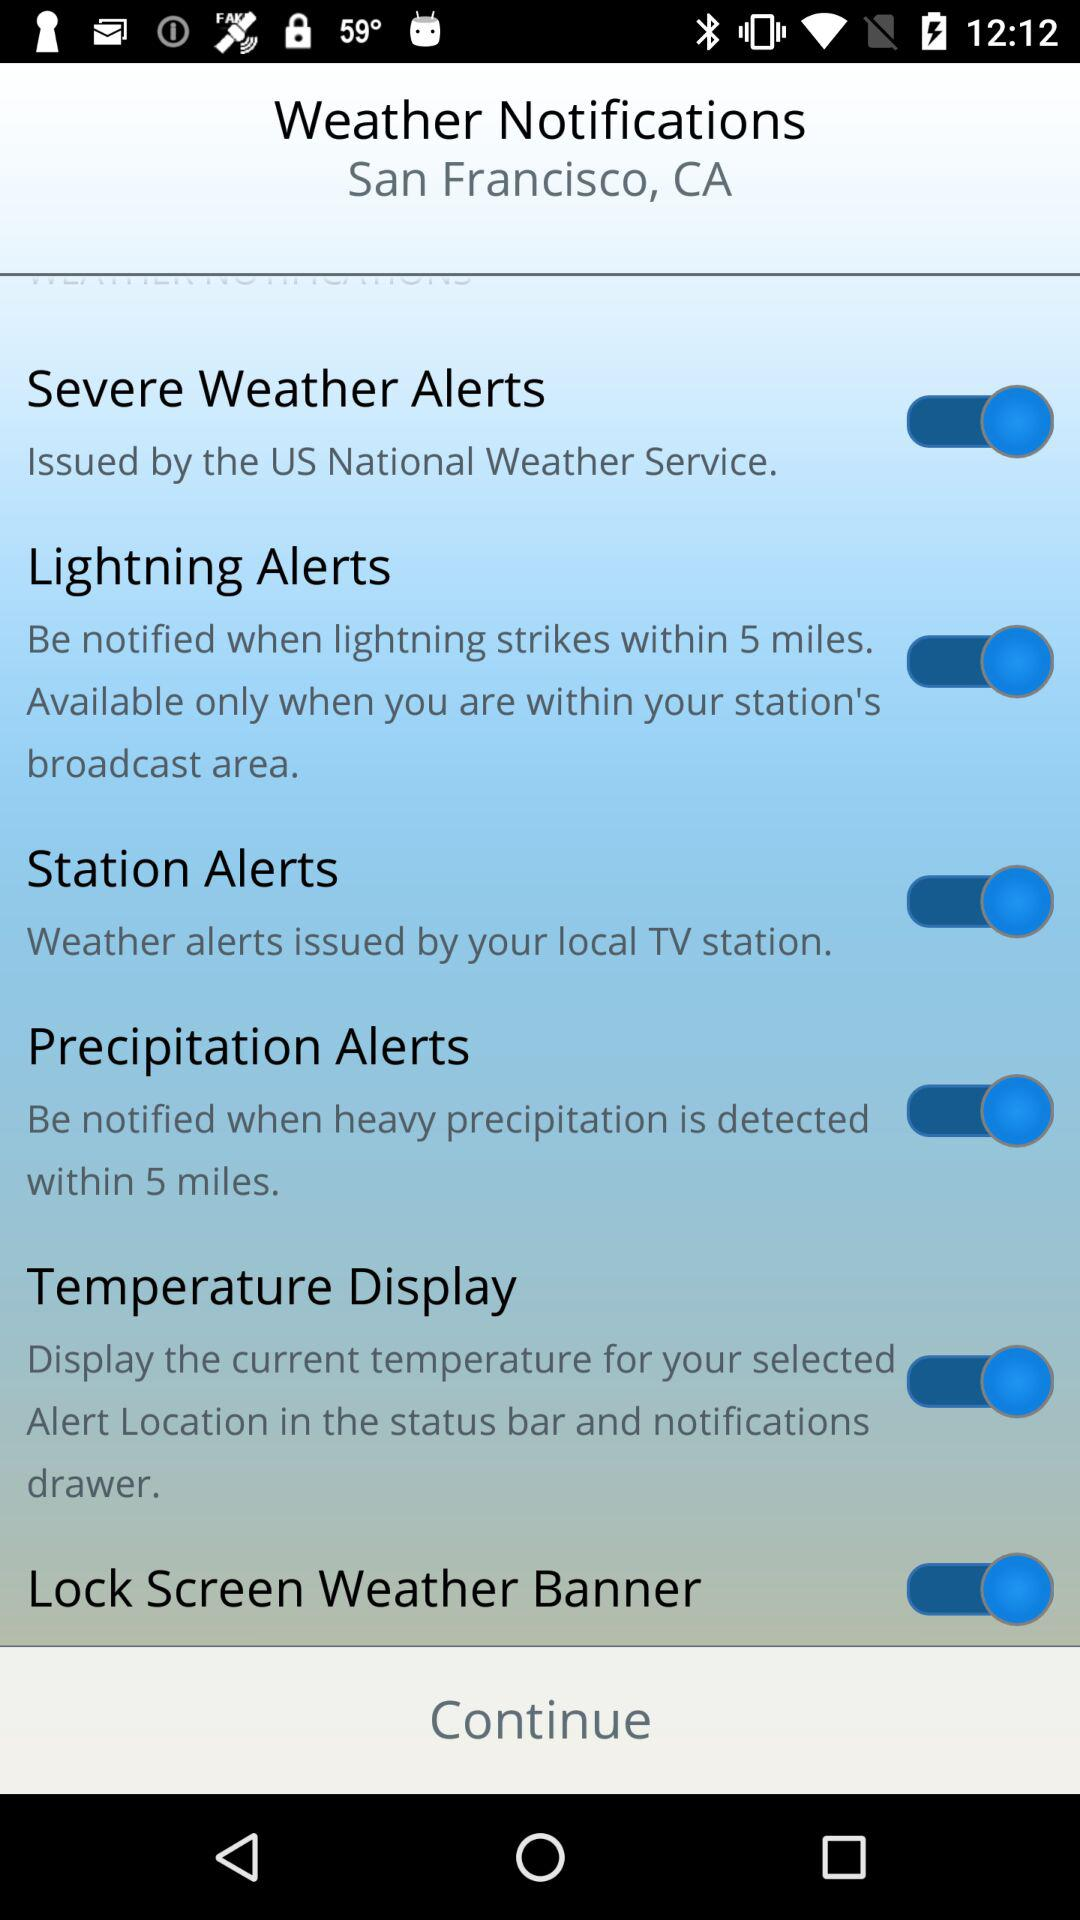What is the location? The location is San Francisco, CA. 